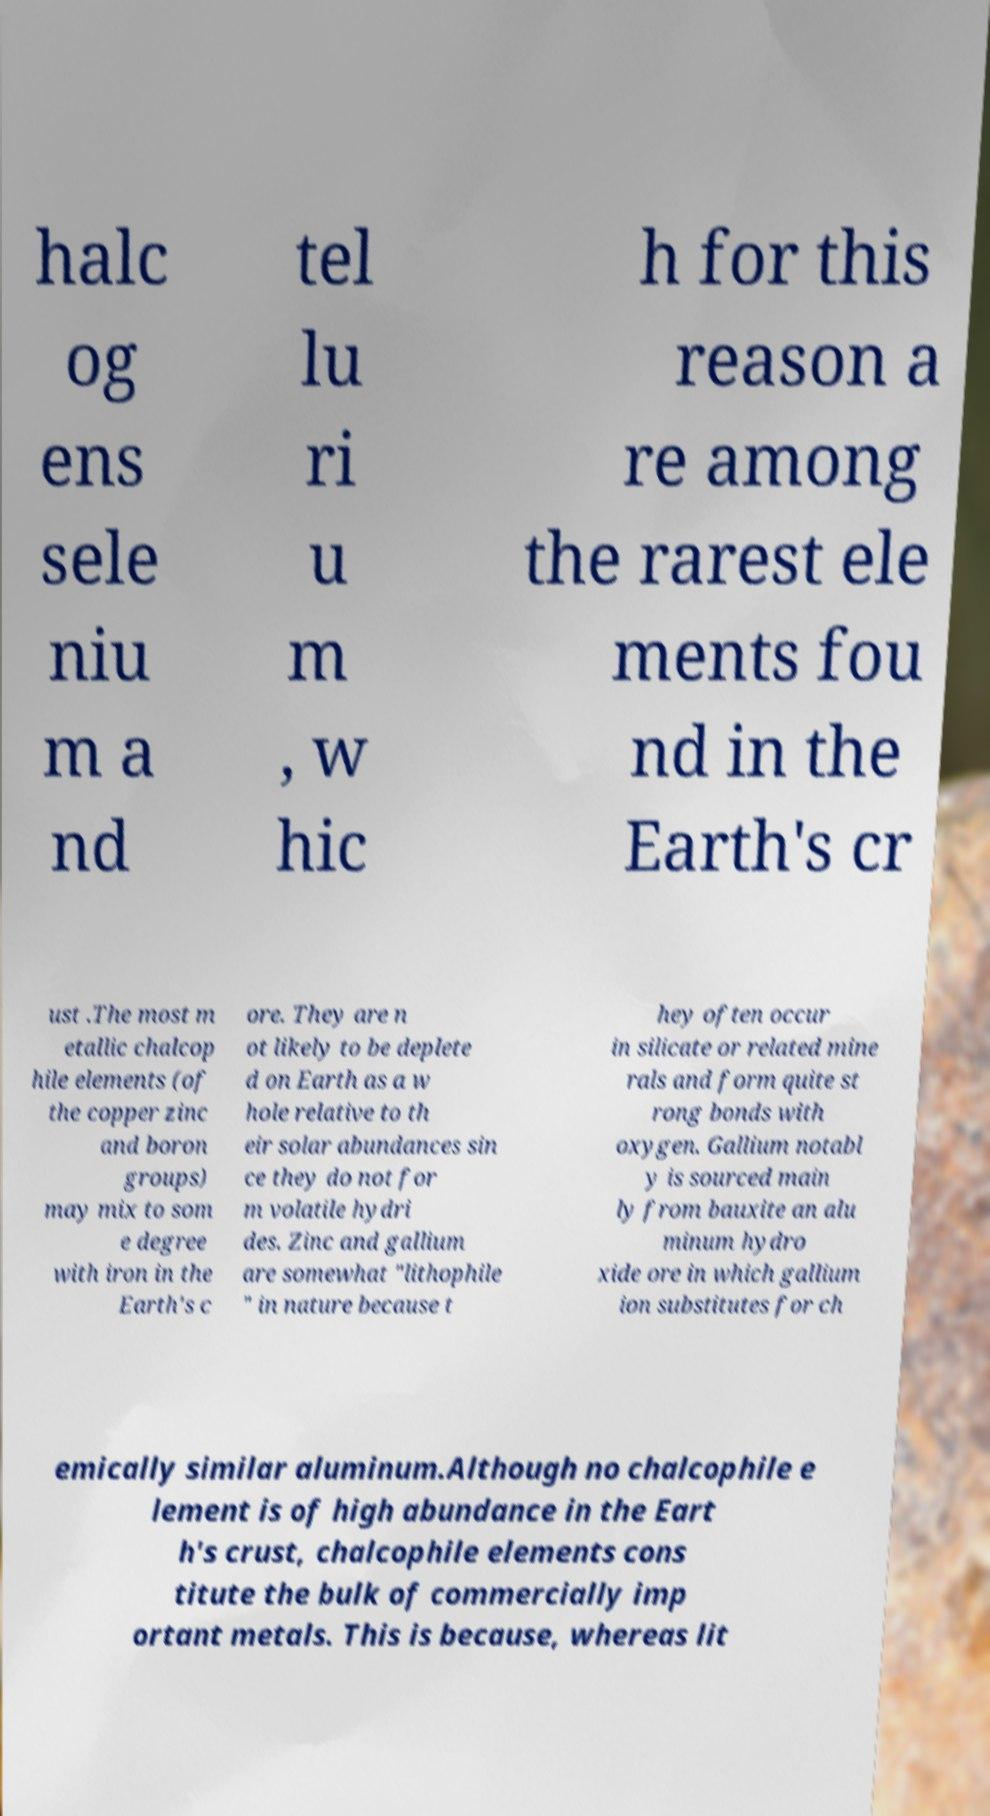For documentation purposes, I need the text within this image transcribed. Could you provide that? halc og ens sele niu m a nd tel lu ri u m , w hic h for this reason a re among the rarest ele ments fou nd in the Earth's cr ust .The most m etallic chalcop hile elements (of the copper zinc and boron groups) may mix to som e degree with iron in the Earth's c ore. They are n ot likely to be deplete d on Earth as a w hole relative to th eir solar abundances sin ce they do not for m volatile hydri des. Zinc and gallium are somewhat "lithophile " in nature because t hey often occur in silicate or related mine rals and form quite st rong bonds with oxygen. Gallium notabl y is sourced main ly from bauxite an alu minum hydro xide ore in which gallium ion substitutes for ch emically similar aluminum.Although no chalcophile e lement is of high abundance in the Eart h's crust, chalcophile elements cons titute the bulk of commercially imp ortant metals. This is because, whereas lit 